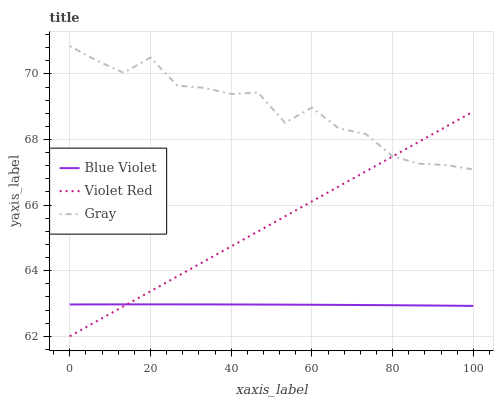Does Blue Violet have the minimum area under the curve?
Answer yes or no. Yes. Does Gray have the maximum area under the curve?
Answer yes or no. Yes. Does Violet Red have the minimum area under the curve?
Answer yes or no. No. Does Violet Red have the maximum area under the curve?
Answer yes or no. No. Is Violet Red the smoothest?
Answer yes or no. Yes. Is Gray the roughest?
Answer yes or no. Yes. Is Blue Violet the smoothest?
Answer yes or no. No. Is Blue Violet the roughest?
Answer yes or no. No. Does Blue Violet have the lowest value?
Answer yes or no. No. Does Gray have the highest value?
Answer yes or no. Yes. Does Violet Red have the highest value?
Answer yes or no. No. Is Blue Violet less than Gray?
Answer yes or no. Yes. Is Gray greater than Blue Violet?
Answer yes or no. Yes. Does Violet Red intersect Blue Violet?
Answer yes or no. Yes. Is Violet Red less than Blue Violet?
Answer yes or no. No. Is Violet Red greater than Blue Violet?
Answer yes or no. No. Does Blue Violet intersect Gray?
Answer yes or no. No. 